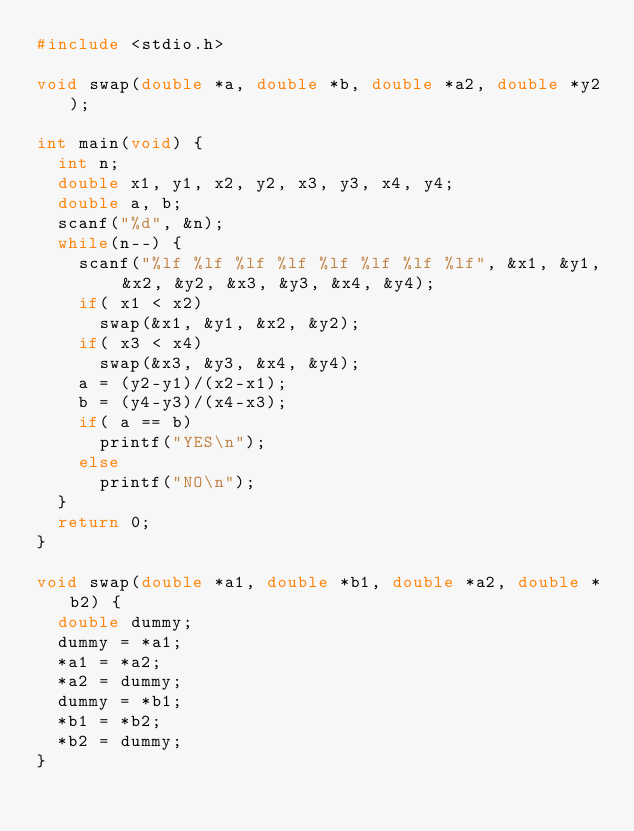<code> <loc_0><loc_0><loc_500><loc_500><_C_>#include <stdio.h>

void swap(double *a, double *b, double *a2, double *y2);

int main(void) {
	int n;
	double x1, y1, x2, y2, x3, y3, x4, y4;
	double a, b;
	scanf("%d", &n);
	while(n--) {
		scanf("%lf %lf %lf %lf %lf %lf %lf %lf", &x1, &y1, &x2, &y2, &x3, &y3, &x4, &y4);
		if( x1 < x2)
			swap(&x1, &y1, &x2, &y2);
		if( x3 < x4)
			swap(&x3, &y3, &x4, &y4);
		a = (y2-y1)/(x2-x1);
		b = (y4-y3)/(x4-x3);
		if( a == b)
			printf("YES\n");
		else
			printf("NO\n");
	}
	return 0;
}

void swap(double *a1, double *b1, double *a2, double *b2) {
	double dummy;
	dummy = *a1;
	*a1 = *a2;
	*a2 = dummy;
	dummy = *b1;
	*b1 = *b2;
	*b2 = dummy;
}</code> 